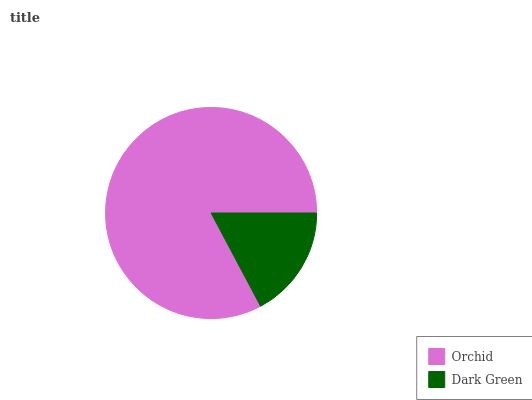Is Dark Green the minimum?
Answer yes or no. Yes. Is Orchid the maximum?
Answer yes or no. Yes. Is Dark Green the maximum?
Answer yes or no. No. Is Orchid greater than Dark Green?
Answer yes or no. Yes. Is Dark Green less than Orchid?
Answer yes or no. Yes. Is Dark Green greater than Orchid?
Answer yes or no. No. Is Orchid less than Dark Green?
Answer yes or no. No. Is Orchid the high median?
Answer yes or no. Yes. Is Dark Green the low median?
Answer yes or no. Yes. Is Dark Green the high median?
Answer yes or no. No. Is Orchid the low median?
Answer yes or no. No. 